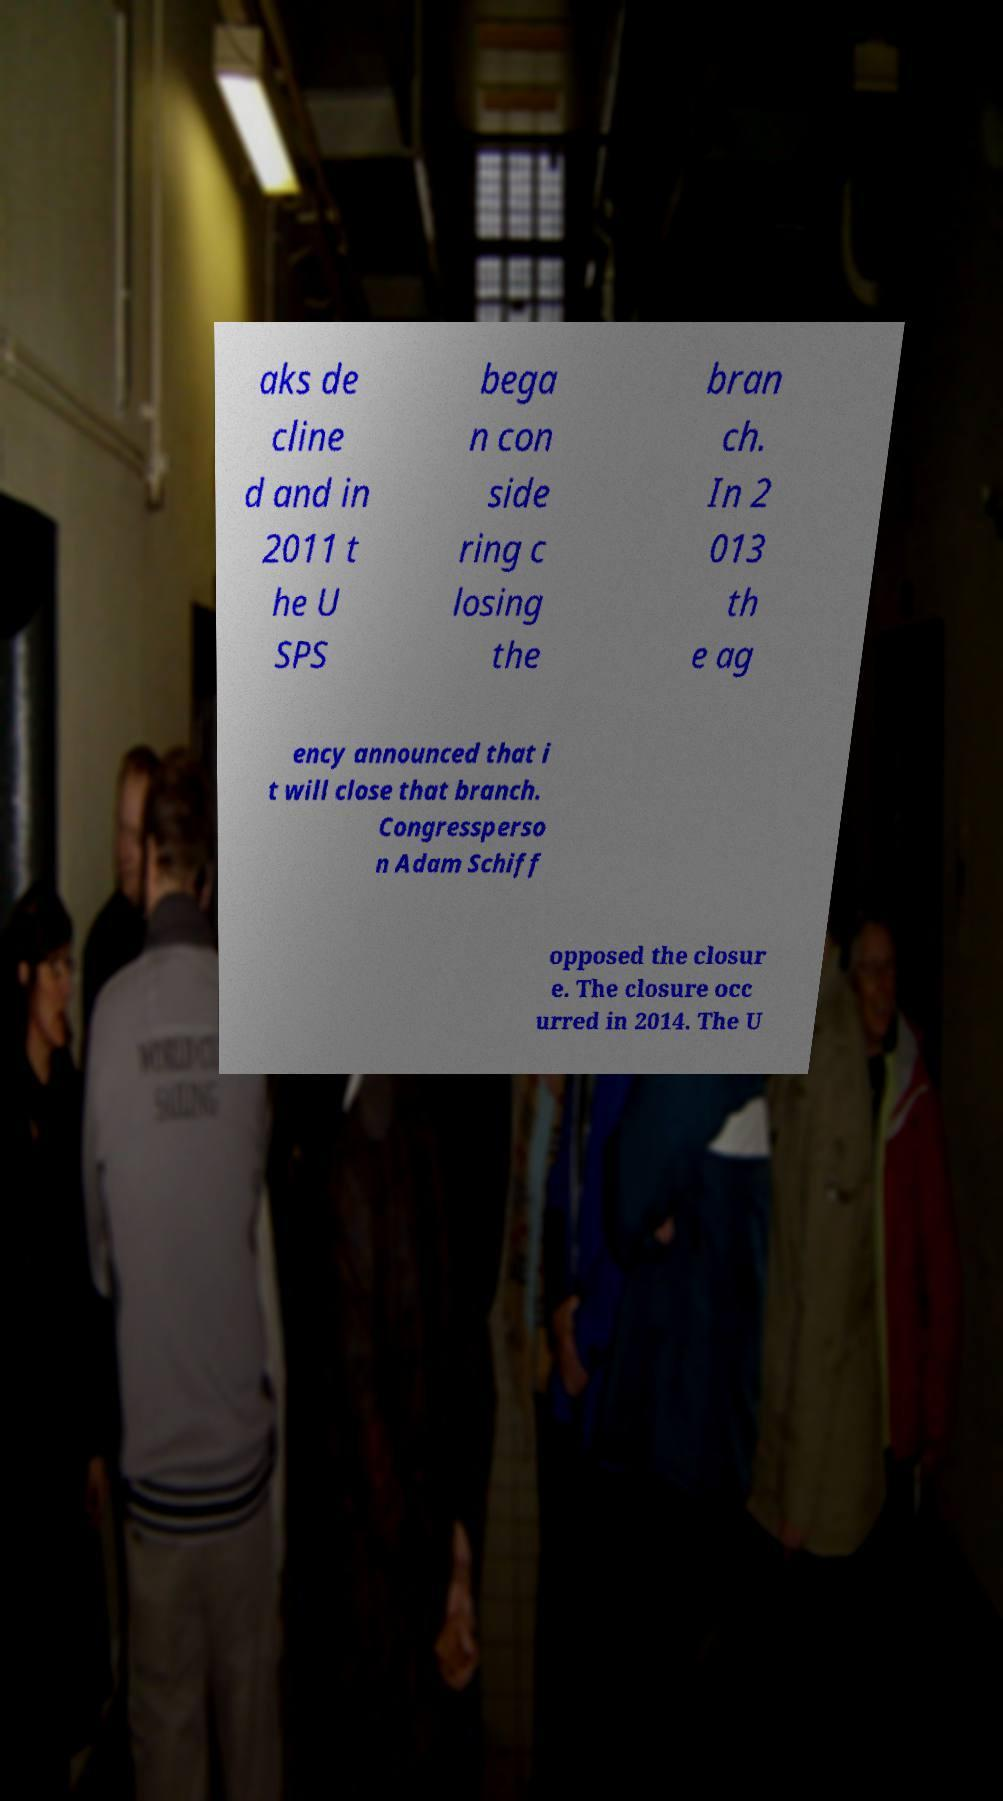Please identify and transcribe the text found in this image. aks de cline d and in 2011 t he U SPS bega n con side ring c losing the bran ch. In 2 013 th e ag ency announced that i t will close that branch. Congressperso n Adam Schiff opposed the closur e. The closure occ urred in 2014. The U 